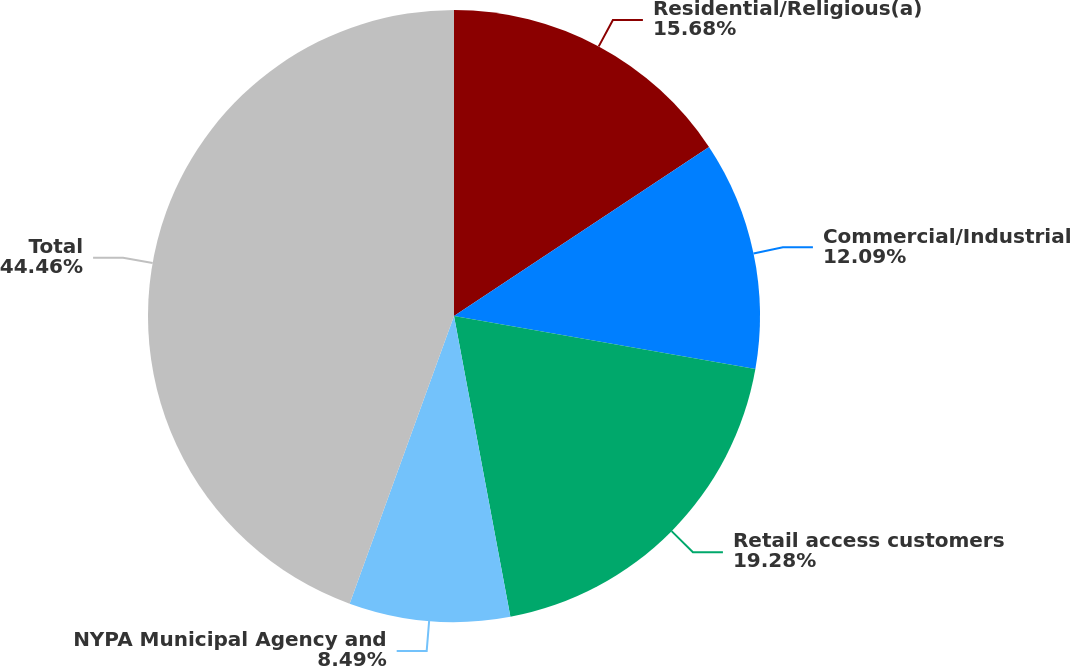Convert chart. <chart><loc_0><loc_0><loc_500><loc_500><pie_chart><fcel>Residential/Religious(a)<fcel>Commercial/Industrial<fcel>Retail access customers<fcel>NYPA Municipal Agency and<fcel>Total<nl><fcel>15.68%<fcel>12.09%<fcel>19.28%<fcel>8.49%<fcel>44.46%<nl></chart> 